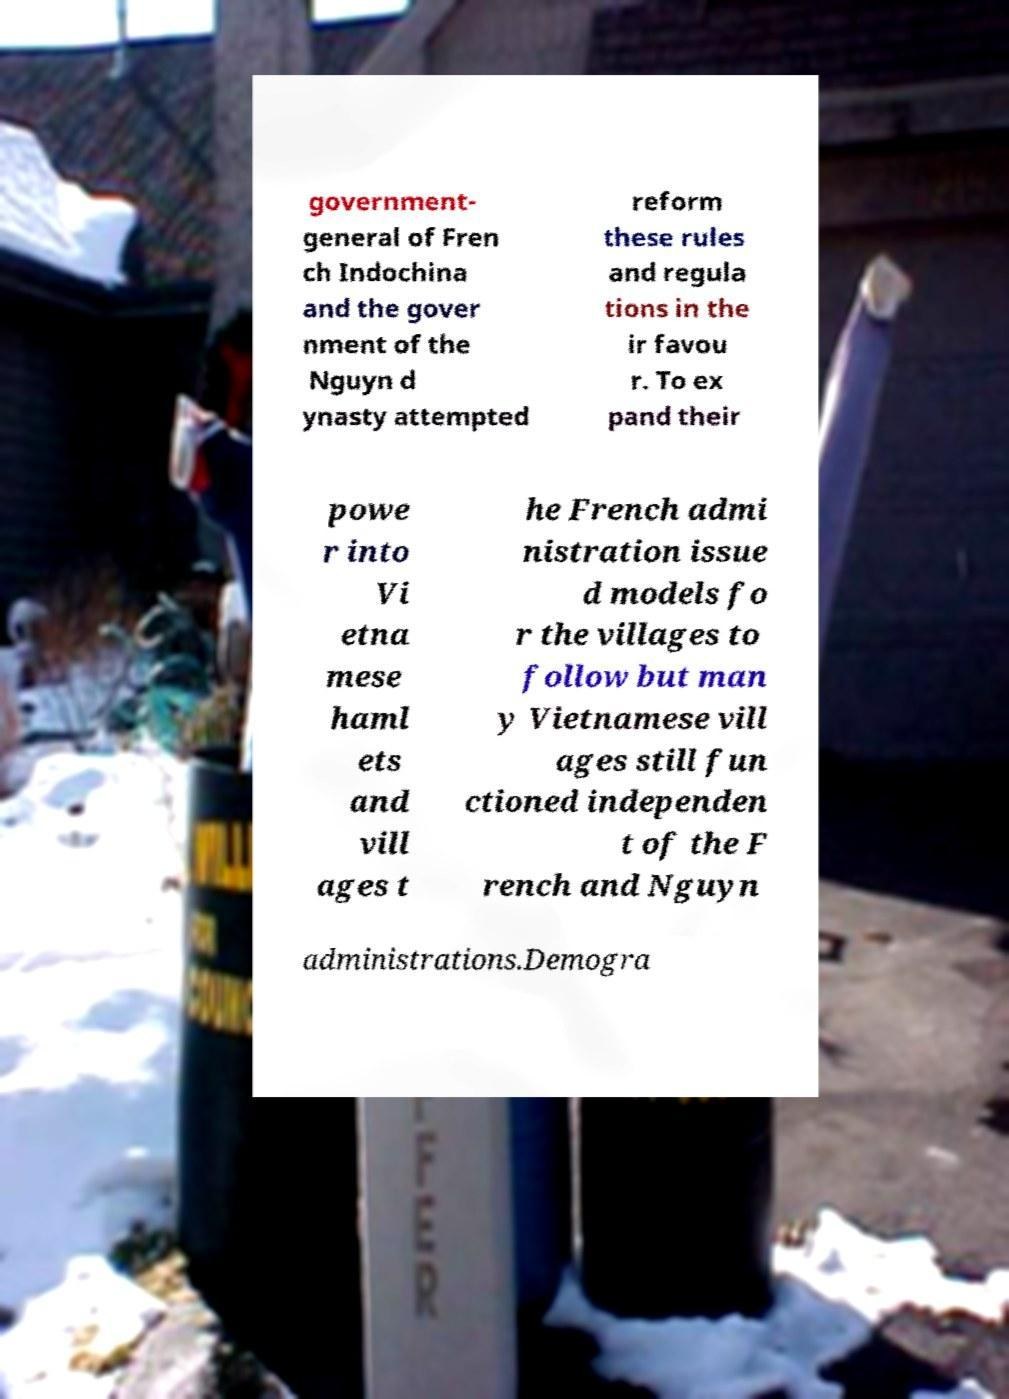For documentation purposes, I need the text within this image transcribed. Could you provide that? government- general of Fren ch Indochina and the gover nment of the Nguyn d ynasty attempted reform these rules and regula tions in the ir favou r. To ex pand their powe r into Vi etna mese haml ets and vill ages t he French admi nistration issue d models fo r the villages to follow but man y Vietnamese vill ages still fun ctioned independen t of the F rench and Nguyn administrations.Demogra 